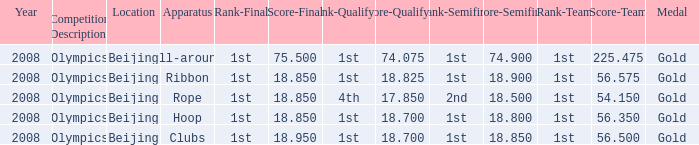What was her lowest final score with a qualifying score of 74.075? 75.5. 